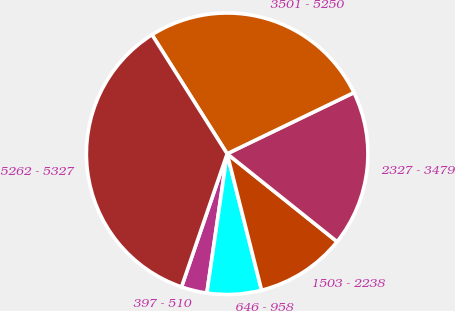Convert chart. <chart><loc_0><loc_0><loc_500><loc_500><pie_chart><fcel>397 - 510<fcel>646 - 958<fcel>1503 - 2238<fcel>2327 - 3479<fcel>3501 - 5250<fcel>5262 - 5327<nl><fcel>2.95%<fcel>6.24%<fcel>10.33%<fcel>17.89%<fcel>26.81%<fcel>35.78%<nl></chart> 